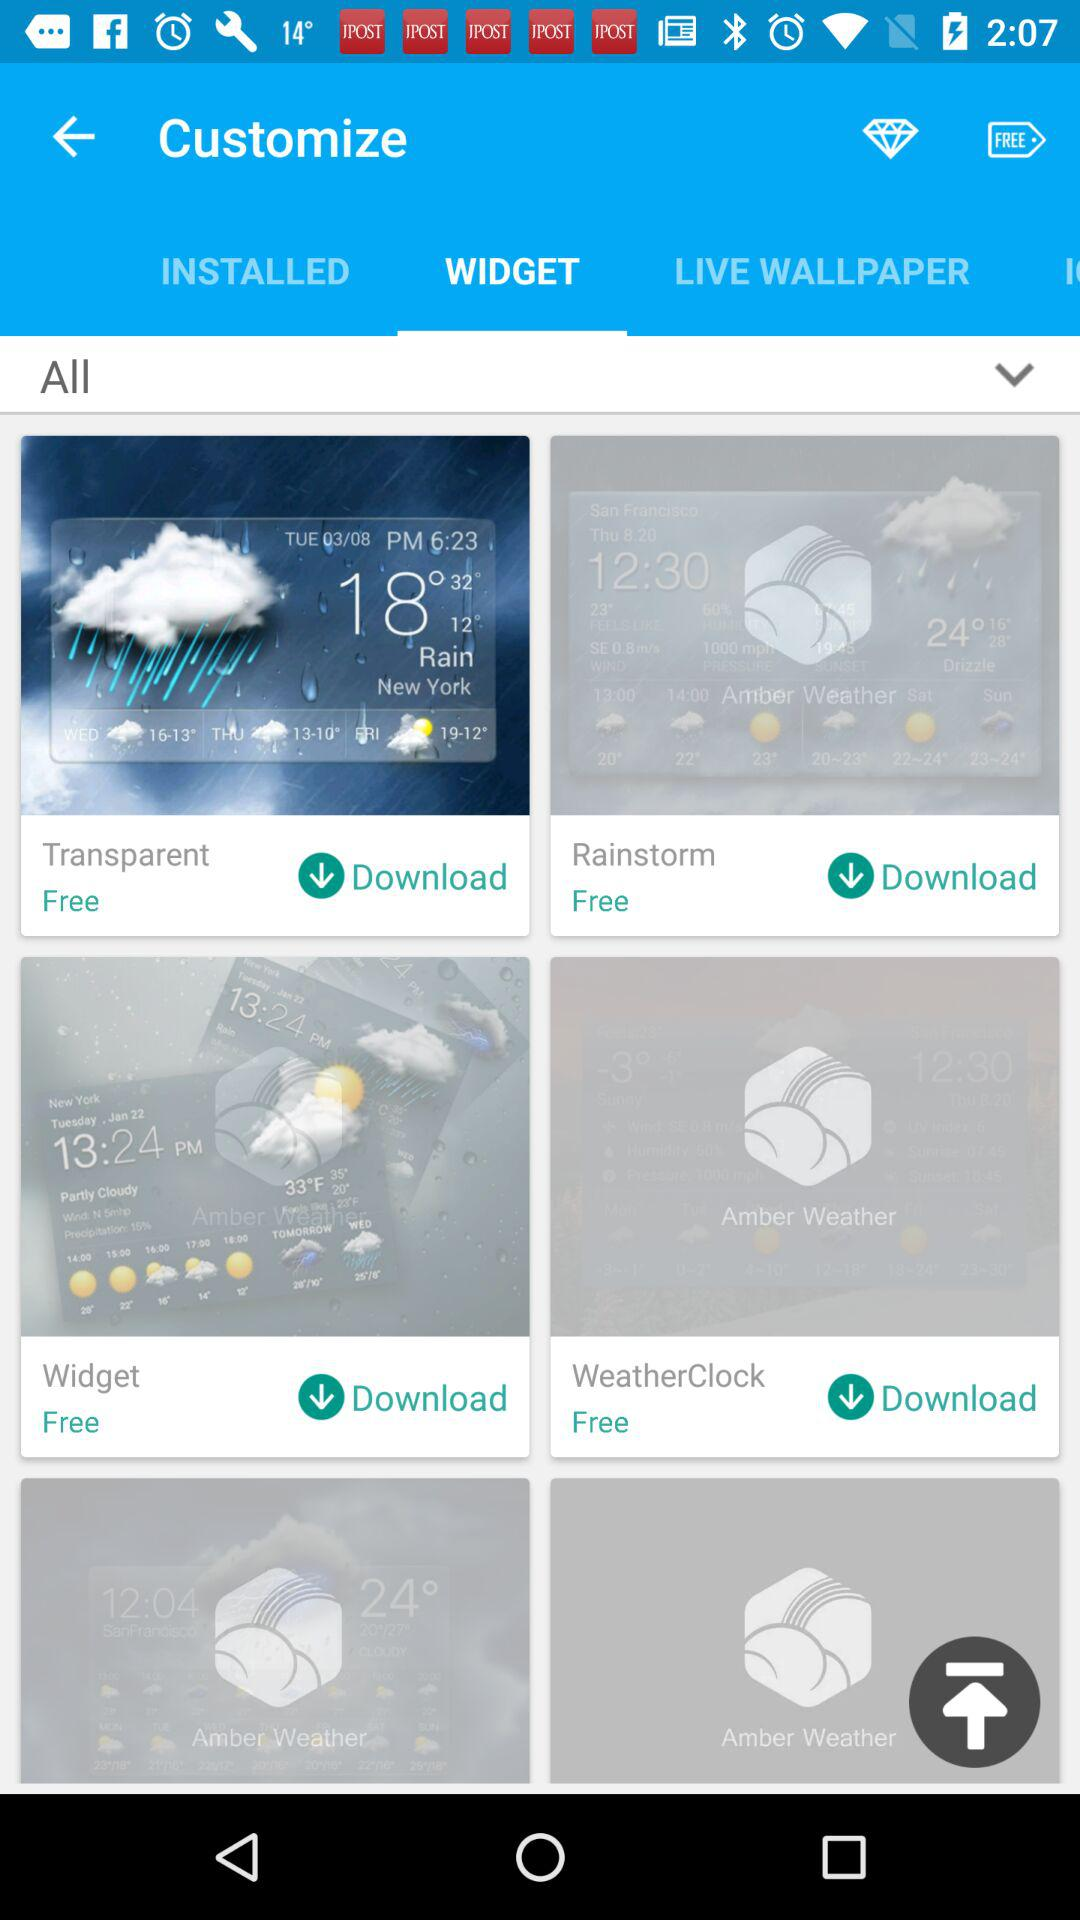How many items have the price 'Free'?
Answer the question using a single word or phrase. 4 